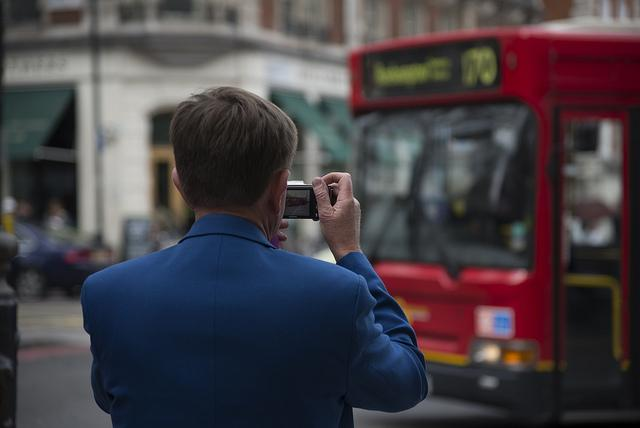What is the person in blue coat doing?

Choices:
A) sending email
B) taking photo
C) watching video
D) online shopping taking photo 